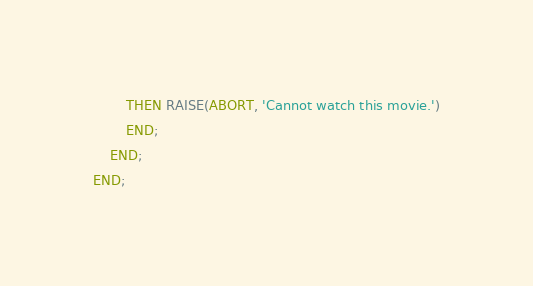Convert code to text. <code><loc_0><loc_0><loc_500><loc_500><_SQL_>        THEN RAISE(ABORT, 'Cannot watch this movie.')
        END;
    END;
END;
</code> 